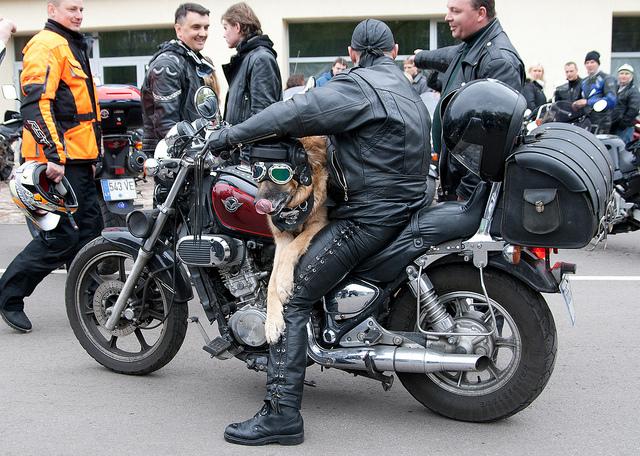Where are the bikes?
Write a very short answer. On road. What kind of pants is the man wearing?
Be succinct. Leather. How many people are wearing orange shirts?
Keep it brief. 1. What kind of paint job does the bike have?
Give a very brief answer. Red. How many people can the motorcycle fit on it?
Quick response, please. 2. What is on the man's head?
Concise answer only. Bandana. Is that a police officer?
Answer briefly. No. What is wearing green goggles?
Quick response, please. Dog. 